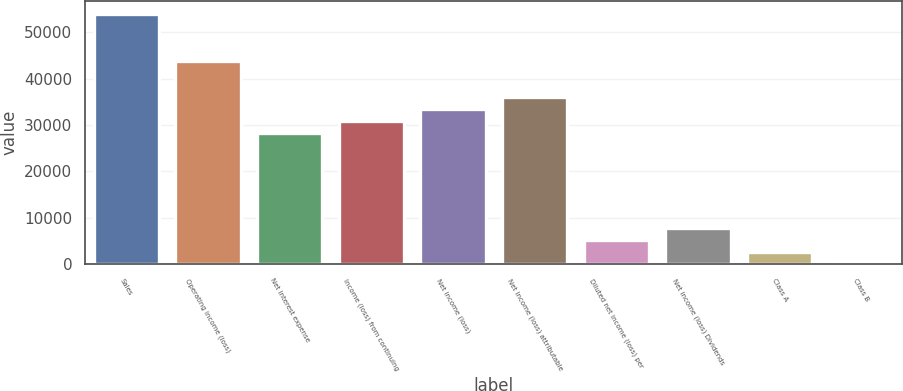Convert chart to OTSL. <chart><loc_0><loc_0><loc_500><loc_500><bar_chart><fcel>Sales<fcel>Operating income (loss)<fcel>Net interest expense<fcel>Income (loss) from continuing<fcel>Net income (loss)<fcel>Net income (loss) attributable<fcel>Diluted net income (loss) per<fcel>Net income (loss) Dividends<fcel>Class A<fcel>Class B<nl><fcel>54030.8<fcel>43739.3<fcel>28301.9<fcel>30874.8<fcel>33447.7<fcel>36020.6<fcel>5145.92<fcel>7718.81<fcel>2573.03<fcel>0.14<nl></chart> 